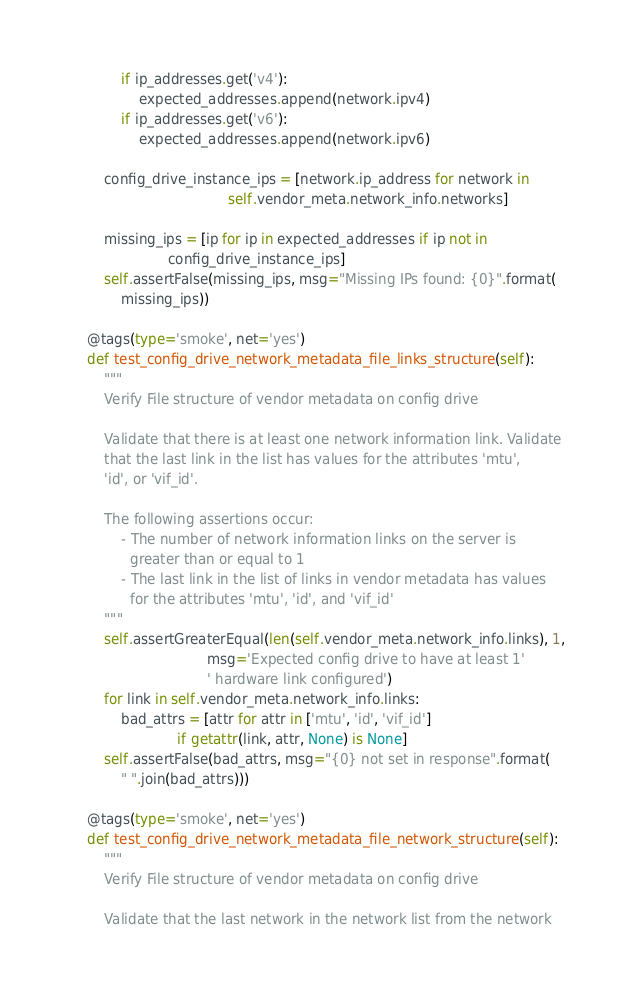Convert code to text. <code><loc_0><loc_0><loc_500><loc_500><_Python_>            if ip_addresses.get('v4'):
                expected_addresses.append(network.ipv4)
            if ip_addresses.get('v6'):
                expected_addresses.append(network.ipv6)

        config_drive_instance_ips = [network.ip_address for network in
                                     self.vendor_meta.network_info.networks]

        missing_ips = [ip for ip in expected_addresses if ip not in
                       config_drive_instance_ips]
        self.assertFalse(missing_ips, msg="Missing IPs found: {0}".format(
            missing_ips))

    @tags(type='smoke', net='yes')
    def test_config_drive_network_metadata_file_links_structure(self):
        """
        Verify File structure of vendor metadata on config drive

        Validate that there is at least one network information link. Validate
        that the last link in the list has values for the attributes 'mtu',
        'id', or 'vif_id'.

        The following assertions occur:
            - The number of network information links on the server is
              greater than or equal to 1
            - The last link in the list of links in vendor metadata has values
              for the attributes 'mtu', 'id', and 'vif_id'
        """
        self.assertGreaterEqual(len(self.vendor_meta.network_info.links), 1,
                                msg='Expected config drive to have at least 1'
                                ' hardware link configured')
        for link in self.vendor_meta.network_info.links:
            bad_attrs = [attr for attr in ['mtu', 'id', 'vif_id']
                         if getattr(link, attr, None) is None]
        self.assertFalse(bad_attrs, msg="{0} not set in response".format(
            " ".join(bad_attrs)))

    @tags(type='smoke', net='yes')
    def test_config_drive_network_metadata_file_network_structure(self):
        """
        Verify File structure of vendor metadata on config drive

        Validate that the last network in the network list from the network</code> 